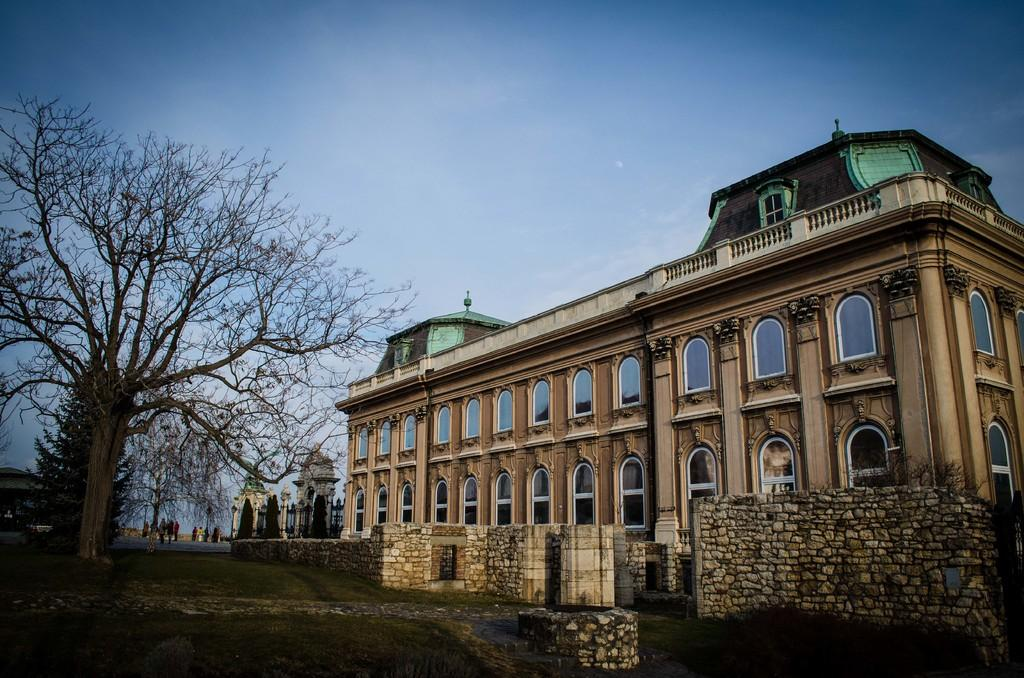What type of structure is present in the image? There is a building in the image. What feature can be observed on the building? The building has glass windows. What else is visible in the image besides the building? There are trees in the image. What material is used for the walls of the building? The building has stone walls. Are there any people present in the image? Yes, there are people in the image. What is the color of the sky in the image? The sky is blue in color. What emotion can be seen on the hands of the people in the image? There is no mention of hands or emotions in the image; it only describes the building, trees, people, and sky. 